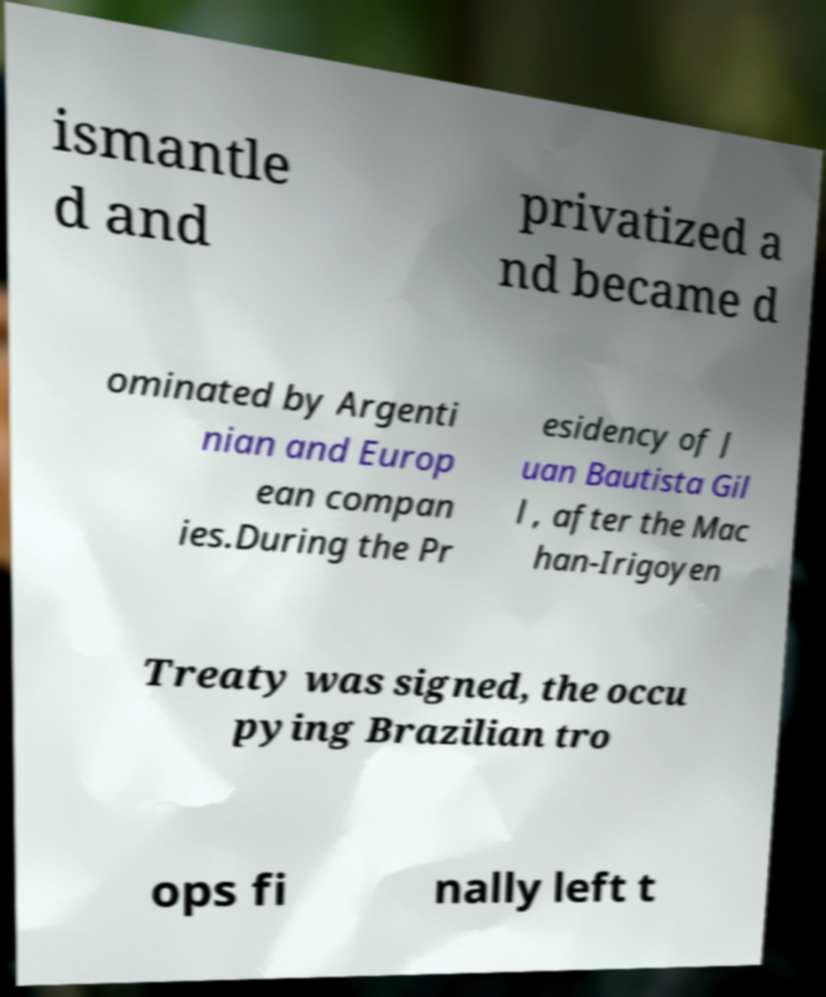Could you assist in decoding the text presented in this image and type it out clearly? ismantle d and privatized a nd became d ominated by Argenti nian and Europ ean compan ies.During the Pr esidency of J uan Bautista Gil l , after the Mac han-Irigoyen Treaty was signed, the occu pying Brazilian tro ops fi nally left t 